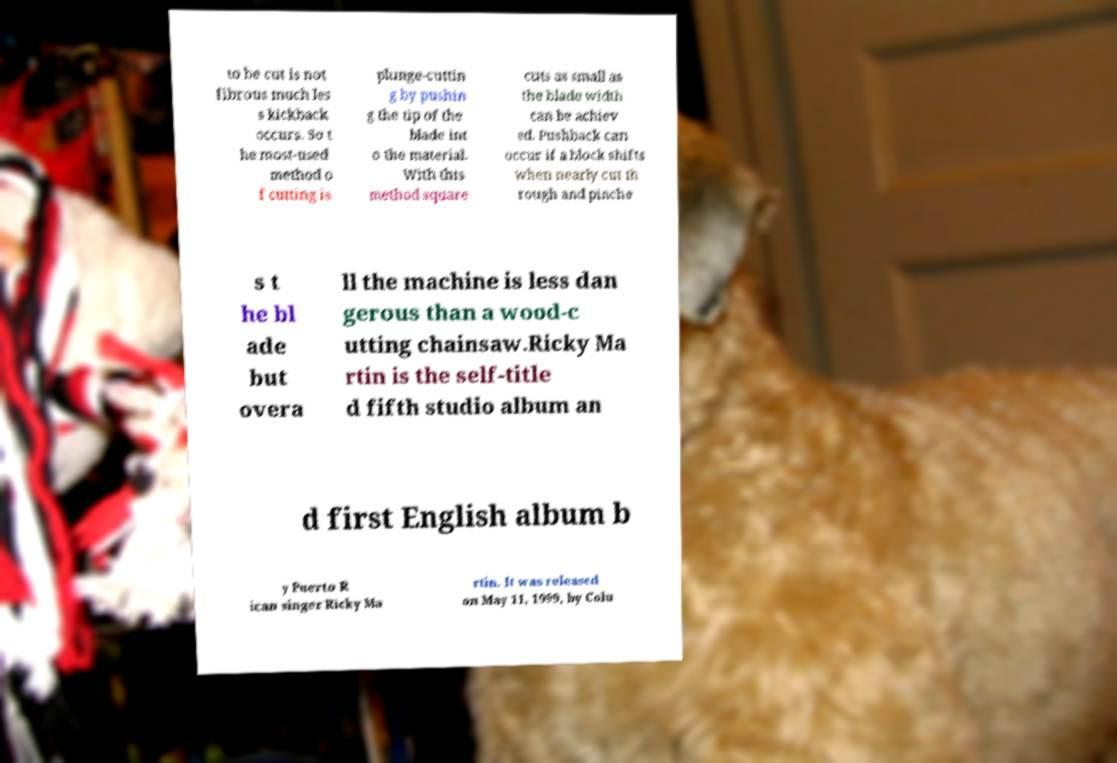Please identify and transcribe the text found in this image. to be cut is not fibrous much les s kickback occurs. So t he most-used method o f cutting is plunge-cuttin g by pushin g the tip of the blade int o the material. With this method square cuts as small as the blade width can be achiev ed. Pushback can occur if a block shifts when nearly cut th rough and pinche s t he bl ade but overa ll the machine is less dan gerous than a wood-c utting chainsaw.Ricky Ma rtin is the self-title d fifth studio album an d first English album b y Puerto R ican singer Ricky Ma rtin. It was released on May 11, 1999, by Colu 